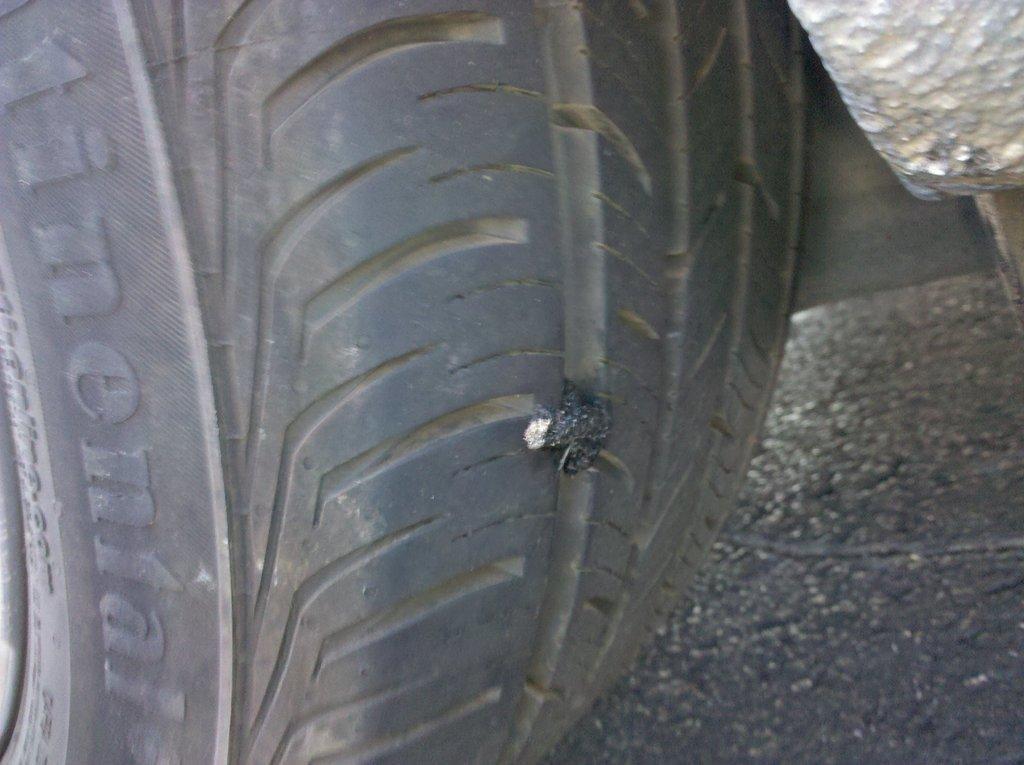Could you give a brief overview of what you see in this image? This is the black tire. I can see a tiny thing, which is attached to the tire. 